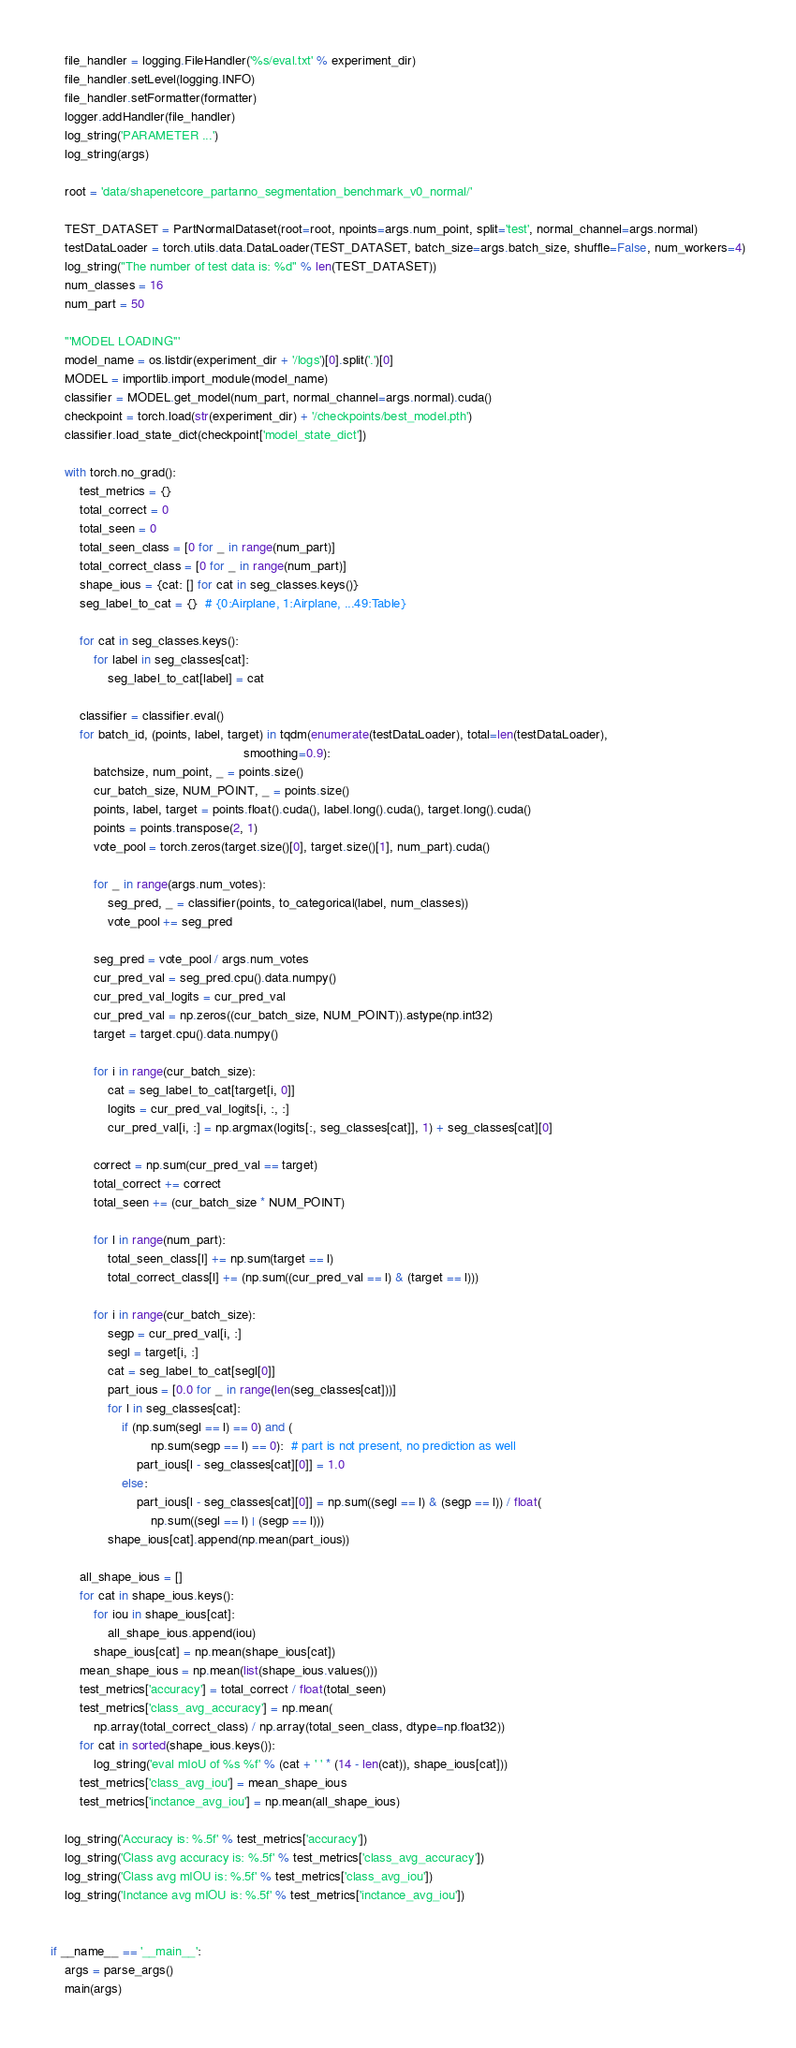Convert code to text. <code><loc_0><loc_0><loc_500><loc_500><_Python_>    file_handler = logging.FileHandler('%s/eval.txt' % experiment_dir)
    file_handler.setLevel(logging.INFO)
    file_handler.setFormatter(formatter)
    logger.addHandler(file_handler)
    log_string('PARAMETER ...')
    log_string(args)

    root = 'data/shapenetcore_partanno_segmentation_benchmark_v0_normal/'

    TEST_DATASET = PartNormalDataset(root=root, npoints=args.num_point, split='test', normal_channel=args.normal)
    testDataLoader = torch.utils.data.DataLoader(TEST_DATASET, batch_size=args.batch_size, shuffle=False, num_workers=4)
    log_string("The number of test data is: %d" % len(TEST_DATASET))
    num_classes = 16
    num_part = 50

    '''MODEL LOADING'''
    model_name = os.listdir(experiment_dir + '/logs')[0].split('.')[0]
    MODEL = importlib.import_module(model_name)
    classifier = MODEL.get_model(num_part, normal_channel=args.normal).cuda()
    checkpoint = torch.load(str(experiment_dir) + '/checkpoints/best_model.pth')
    classifier.load_state_dict(checkpoint['model_state_dict'])

    with torch.no_grad():
        test_metrics = {}
        total_correct = 0
        total_seen = 0
        total_seen_class = [0 for _ in range(num_part)]
        total_correct_class = [0 for _ in range(num_part)]
        shape_ious = {cat: [] for cat in seg_classes.keys()}
        seg_label_to_cat = {}  # {0:Airplane, 1:Airplane, ...49:Table}

        for cat in seg_classes.keys():
            for label in seg_classes[cat]:
                seg_label_to_cat[label] = cat

        classifier = classifier.eval()
        for batch_id, (points, label, target) in tqdm(enumerate(testDataLoader), total=len(testDataLoader),
                                                      smoothing=0.9):
            batchsize, num_point, _ = points.size()
            cur_batch_size, NUM_POINT, _ = points.size()
            points, label, target = points.float().cuda(), label.long().cuda(), target.long().cuda()
            points = points.transpose(2, 1)
            vote_pool = torch.zeros(target.size()[0], target.size()[1], num_part).cuda()

            for _ in range(args.num_votes):
                seg_pred, _ = classifier(points, to_categorical(label, num_classes))
                vote_pool += seg_pred

            seg_pred = vote_pool / args.num_votes
            cur_pred_val = seg_pred.cpu().data.numpy()
            cur_pred_val_logits = cur_pred_val
            cur_pred_val = np.zeros((cur_batch_size, NUM_POINT)).astype(np.int32)
            target = target.cpu().data.numpy()

            for i in range(cur_batch_size):
                cat = seg_label_to_cat[target[i, 0]]
                logits = cur_pred_val_logits[i, :, :]
                cur_pred_val[i, :] = np.argmax(logits[:, seg_classes[cat]], 1) + seg_classes[cat][0]

            correct = np.sum(cur_pred_val == target)
            total_correct += correct
            total_seen += (cur_batch_size * NUM_POINT)

            for l in range(num_part):
                total_seen_class[l] += np.sum(target == l)
                total_correct_class[l] += (np.sum((cur_pred_val == l) & (target == l)))

            for i in range(cur_batch_size):
                segp = cur_pred_val[i, :]
                segl = target[i, :]
                cat = seg_label_to_cat[segl[0]]
                part_ious = [0.0 for _ in range(len(seg_classes[cat]))]
                for l in seg_classes[cat]:
                    if (np.sum(segl == l) == 0) and (
                            np.sum(segp == l) == 0):  # part is not present, no prediction as well
                        part_ious[l - seg_classes[cat][0]] = 1.0
                    else:
                        part_ious[l - seg_classes[cat][0]] = np.sum((segl == l) & (segp == l)) / float(
                            np.sum((segl == l) | (segp == l)))
                shape_ious[cat].append(np.mean(part_ious))

        all_shape_ious = []
        for cat in shape_ious.keys():
            for iou in shape_ious[cat]:
                all_shape_ious.append(iou)
            shape_ious[cat] = np.mean(shape_ious[cat])
        mean_shape_ious = np.mean(list(shape_ious.values()))
        test_metrics['accuracy'] = total_correct / float(total_seen)
        test_metrics['class_avg_accuracy'] = np.mean(
            np.array(total_correct_class) / np.array(total_seen_class, dtype=np.float32))
        for cat in sorted(shape_ious.keys()):
            log_string('eval mIoU of %s %f' % (cat + ' ' * (14 - len(cat)), shape_ious[cat]))
        test_metrics['class_avg_iou'] = mean_shape_ious
        test_metrics['inctance_avg_iou'] = np.mean(all_shape_ious)

    log_string('Accuracy is: %.5f' % test_metrics['accuracy'])
    log_string('Class avg accuracy is: %.5f' % test_metrics['class_avg_accuracy'])
    log_string('Class avg mIOU is: %.5f' % test_metrics['class_avg_iou'])
    log_string('Inctance avg mIOU is: %.5f' % test_metrics['inctance_avg_iou'])


if __name__ == '__main__':
    args = parse_args()
    main(args)
</code> 